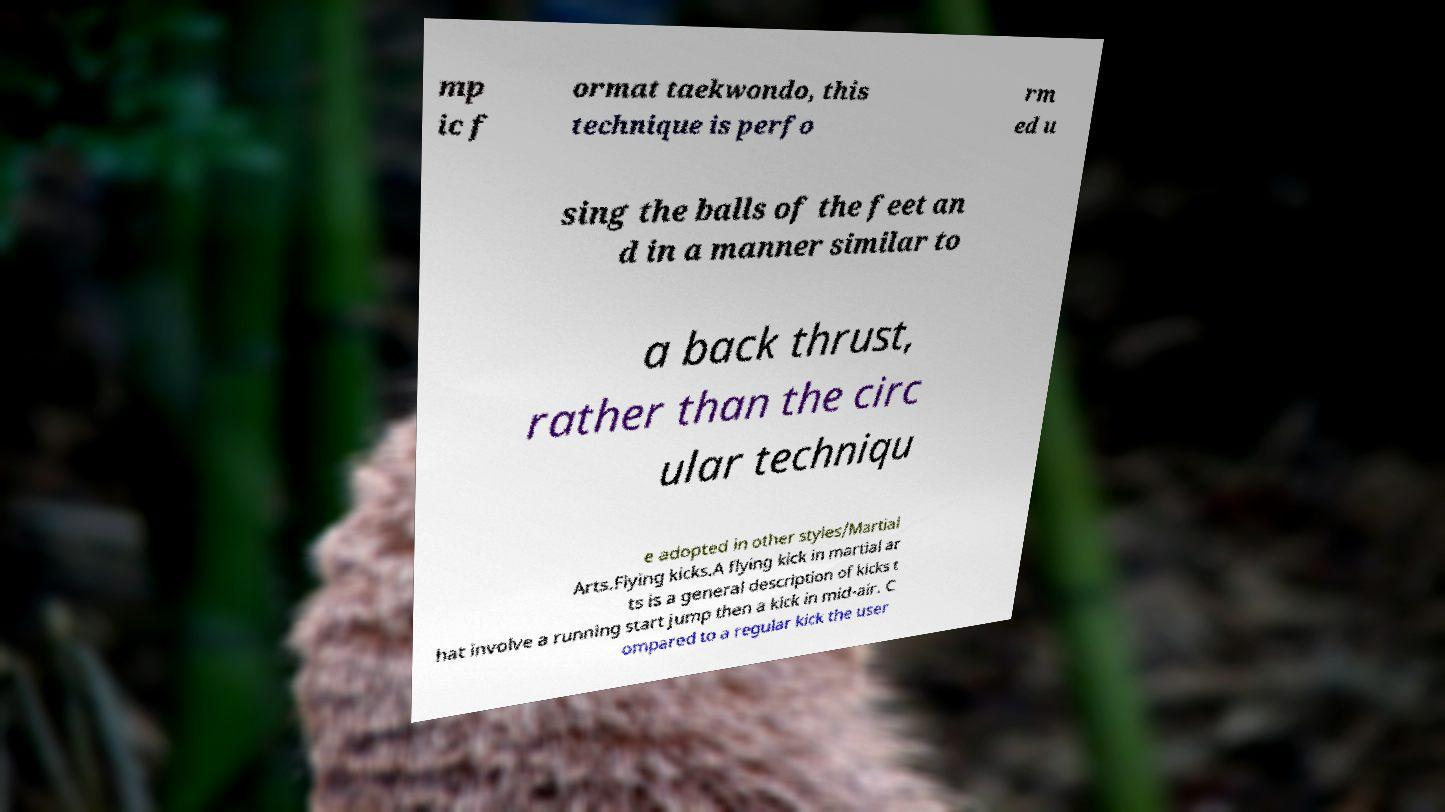Can you accurately transcribe the text from the provided image for me? mp ic f ormat taekwondo, this technique is perfo rm ed u sing the balls of the feet an d in a manner similar to a back thrust, rather than the circ ular techniqu e adopted in other styles/Martial Arts.Flying kicks.A flying kick in martial ar ts is a general description of kicks t hat involve a running start jump then a kick in mid-air. C ompared to a regular kick the user 